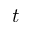Convert formula to latex. <formula><loc_0><loc_0><loc_500><loc_500>t</formula> 